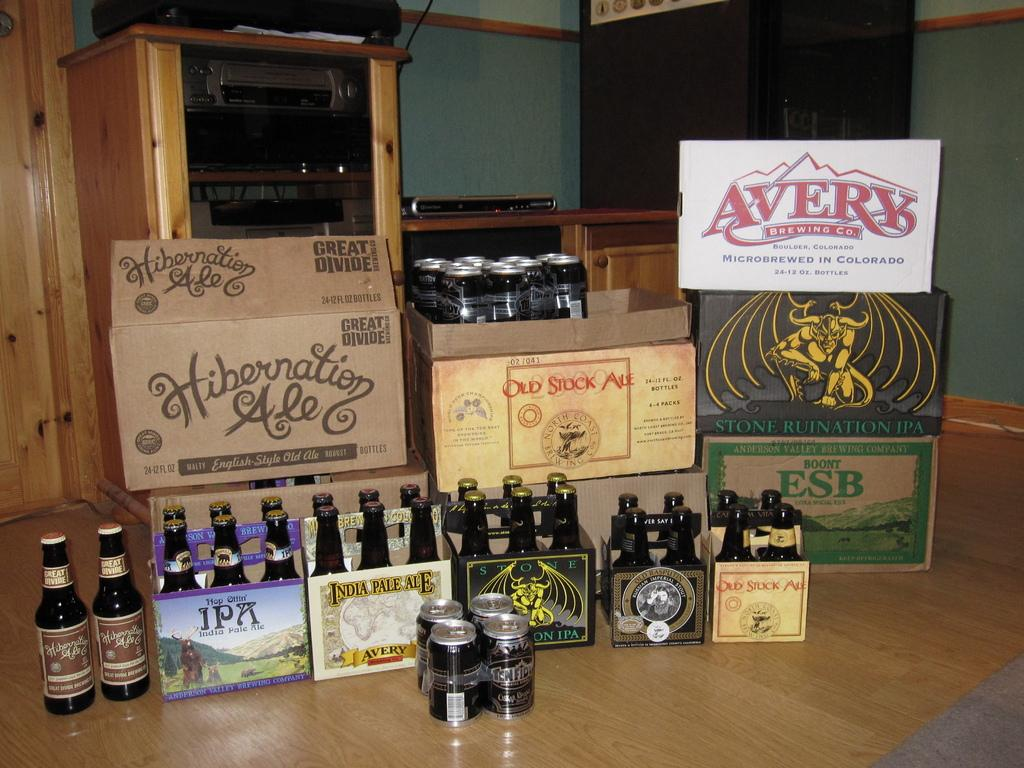<image>
Render a clear and concise summary of the photo. Beer cans with a white label that says AVERY on it. 